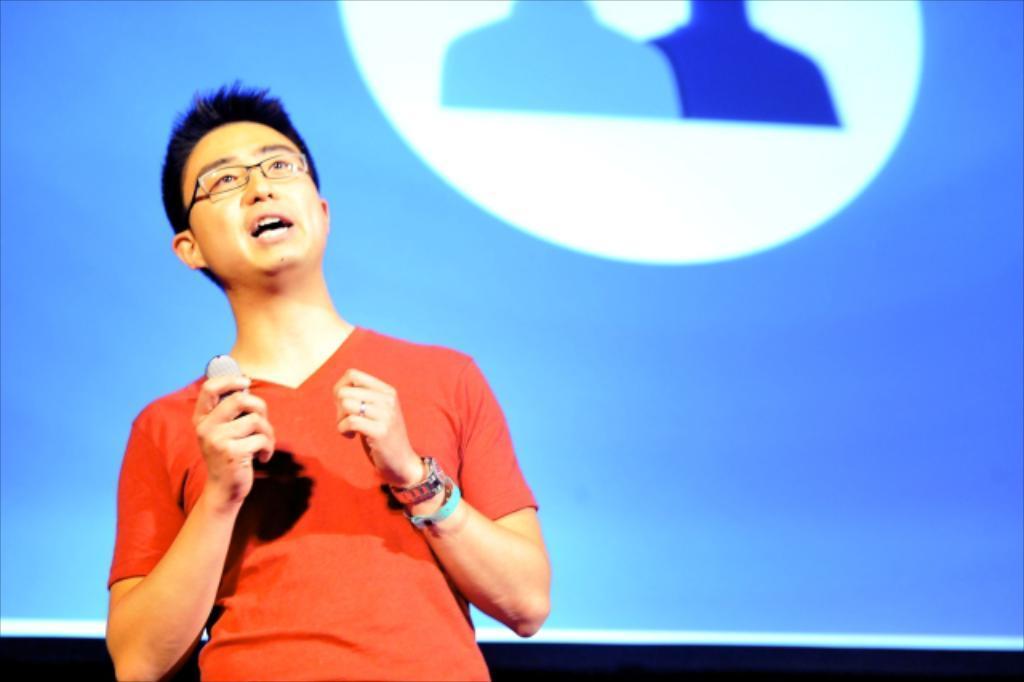Can you describe this image briefly? In this image we can see person standing. In the background we can see screen. 